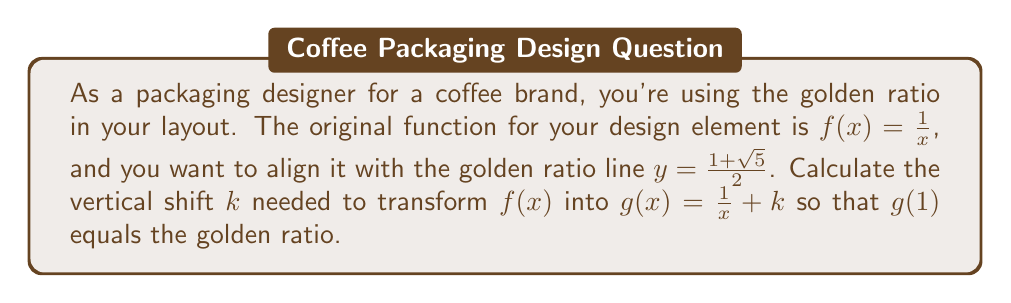Can you answer this question? To solve this problem, we'll follow these steps:

1) The golden ratio is defined as $\frac{1+\sqrt{5}}{2}$. Let's call this value $\phi$.

2) We want $g(1)$ to equal $\phi$. This means:

   $g(1) = \frac{1}{1} + k = 1 + k = \phi$

3) We can express this as an equation:

   $1 + k = \frac{1+\sqrt{5}}{2}$

4) To solve for $k$, subtract 1 from both sides:

   $k = \frac{1+\sqrt{5}}{2} - 1$

5) Simplify the right side:

   $k = \frac{1+\sqrt{5}}{2} - \frac{2}{2} = \frac{1+\sqrt{5}-2}{2} = \frac{-1+\sqrt{5}}{2}$

6) This is our final answer for the vertical shift $k$.

The transformation $g(x) = f(x) + k = \frac{1}{x} + \frac{-1+\sqrt{5}}{2}$ will align the function with the golden ratio at $x=1$.
Answer: $k = \frac{-1+\sqrt{5}}{2}$ 